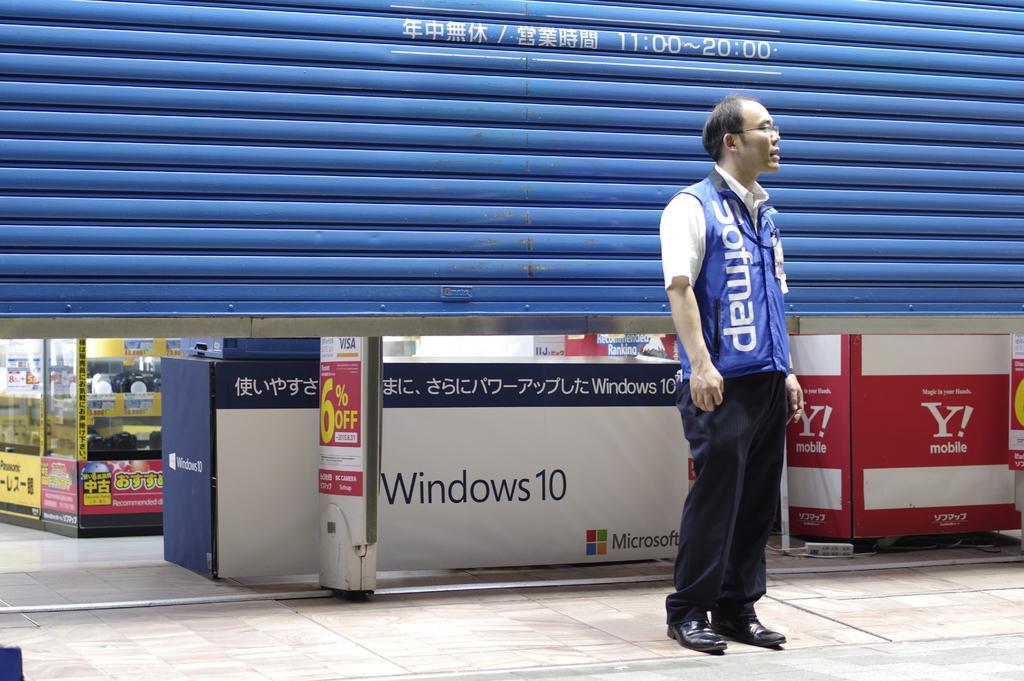Describe this image in one or two sentences. This image consists of a store backside. There is a shutter which is in blue color. In the middle there is a person standing. He is wearing a blue coat. 